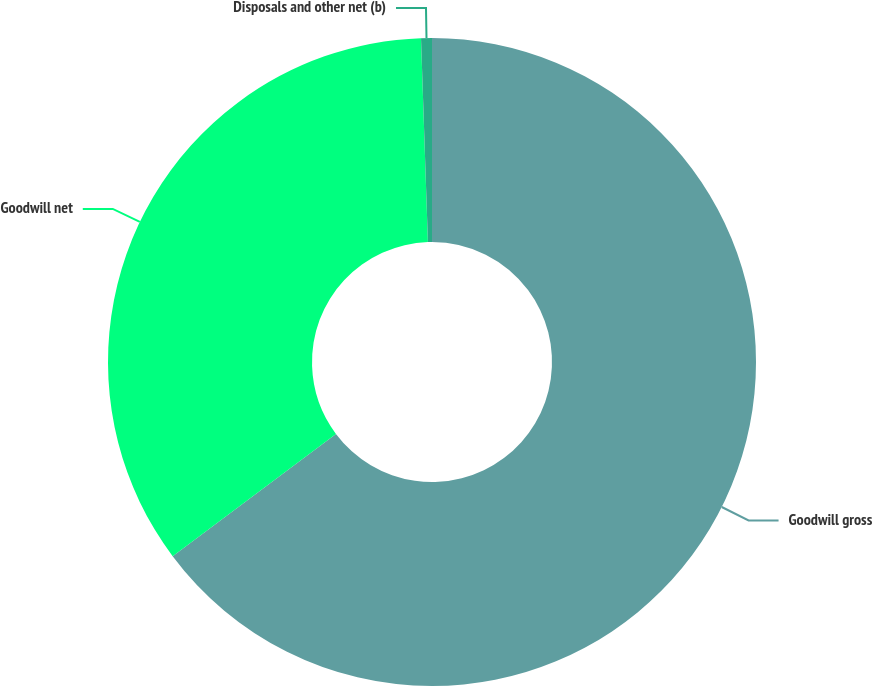Convert chart. <chart><loc_0><loc_0><loc_500><loc_500><pie_chart><fcel>Goodwill gross<fcel>Goodwill net<fcel>Disposals and other net (b)<nl><fcel>64.77%<fcel>34.69%<fcel>0.54%<nl></chart> 